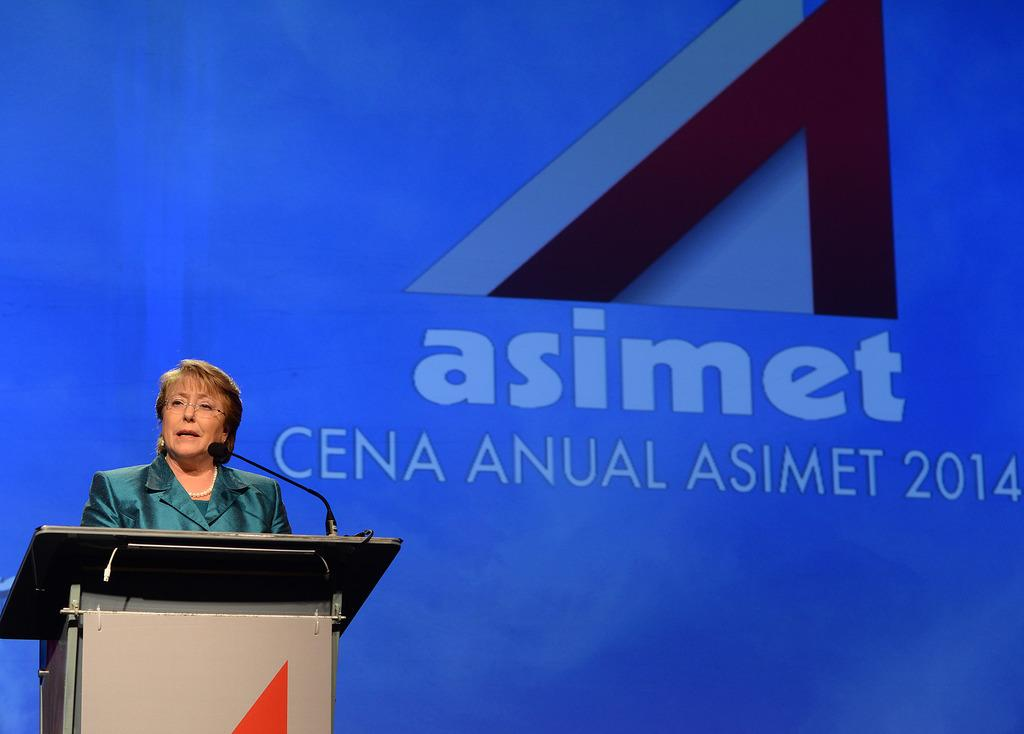Who is the main subject in the image? There is a woman in the image. Where is the woman located in the image? The woman is on the left side of the image. What object is present in the image that is typically used for amplifying sound? There is a microphone in the image. What piece of furniture is present in the image that is often used for public speaking? There is a podium in the image. How is the podium positioned in relation to the woman? The podium is in front of the woman. What can be seen in the background of the image that provides additional information? There is text visible in the background of the image. What type of land is visible in the image? There is no land visible in the image; it is an indoor scene with a woman, microphone, podium, and text in the background. 